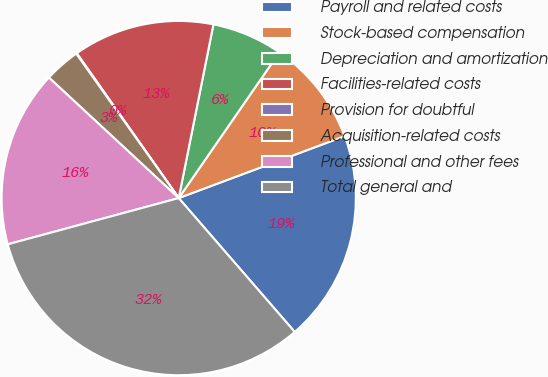Convert chart. <chart><loc_0><loc_0><loc_500><loc_500><pie_chart><fcel>Payroll and related costs<fcel>Stock-based compensation<fcel>Depreciation and amortization<fcel>Facilities-related costs<fcel>Provision for doubtful<fcel>Acquisition-related costs<fcel>Professional and other fees<fcel>Total general and<nl><fcel>19.32%<fcel>9.69%<fcel>6.48%<fcel>12.9%<fcel>0.06%<fcel>3.27%<fcel>16.11%<fcel>32.16%<nl></chart> 